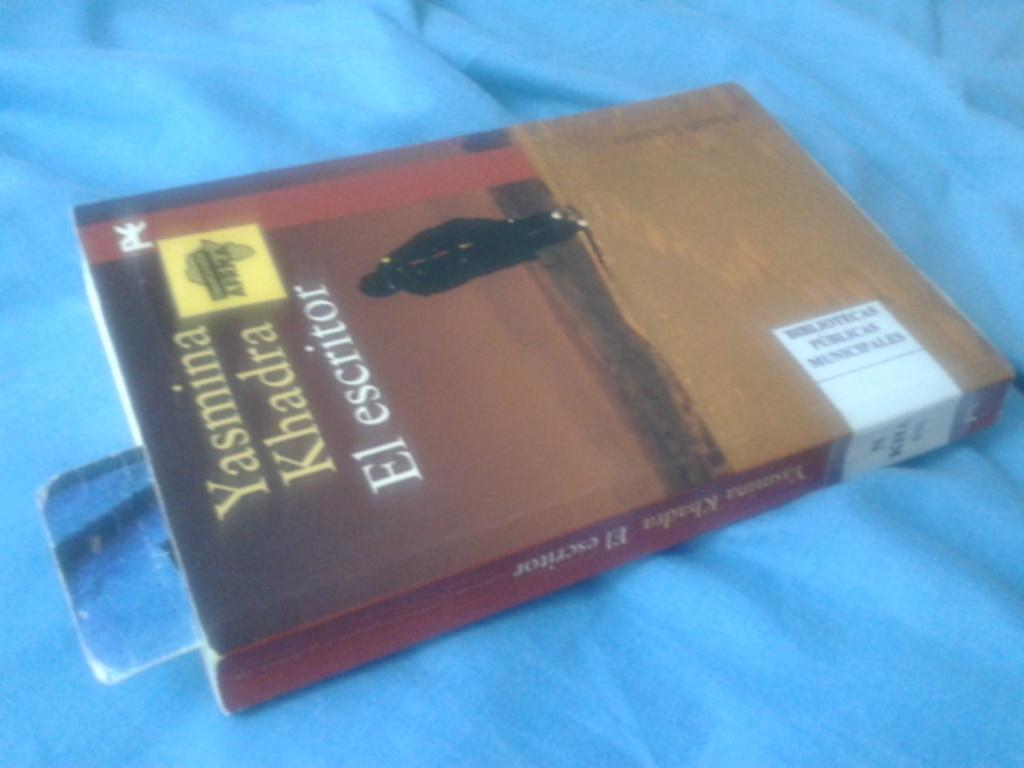<image>
Describe the image concisely. A book called Yasmina Khadra El escritor is on a blue blanket. 